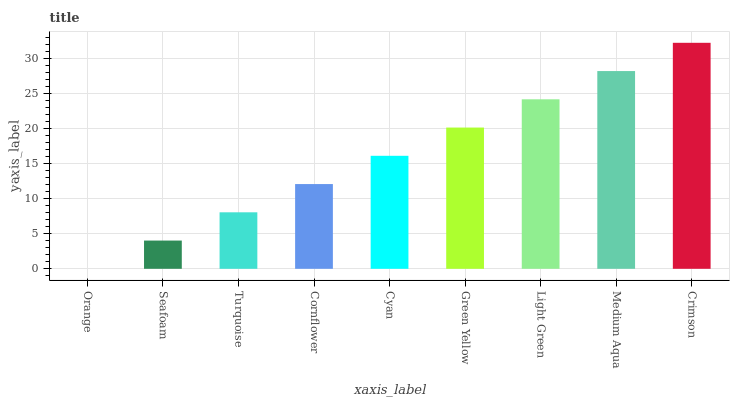Is Orange the minimum?
Answer yes or no. Yes. Is Crimson the maximum?
Answer yes or no. Yes. Is Seafoam the minimum?
Answer yes or no. No. Is Seafoam the maximum?
Answer yes or no. No. Is Seafoam greater than Orange?
Answer yes or no. Yes. Is Orange less than Seafoam?
Answer yes or no. Yes. Is Orange greater than Seafoam?
Answer yes or no. No. Is Seafoam less than Orange?
Answer yes or no. No. Is Cyan the high median?
Answer yes or no. Yes. Is Cyan the low median?
Answer yes or no. Yes. Is Medium Aqua the high median?
Answer yes or no. No. Is Turquoise the low median?
Answer yes or no. No. 